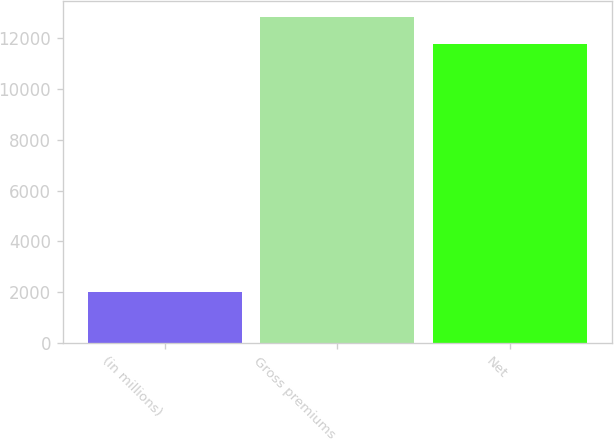Convert chart. <chart><loc_0><loc_0><loc_500><loc_500><bar_chart><fcel>(in millions)<fcel>Gross premiums<fcel>Net<nl><fcel>2010<fcel>12835.1<fcel>11755<nl></chart> 